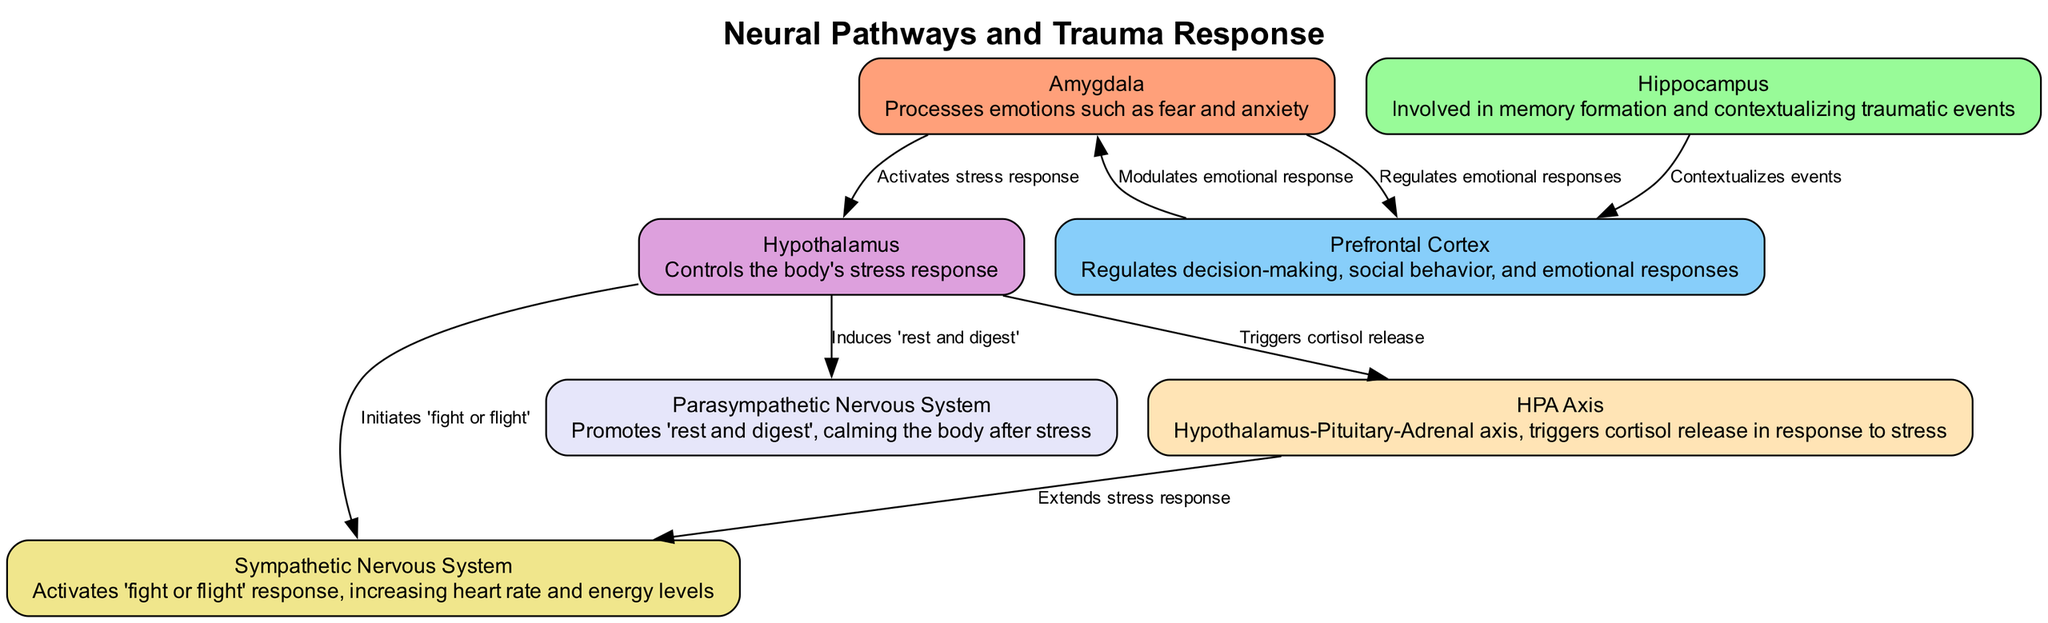What is the role of the amygdala? The amygdala processes emotions, particularly fear and anxiety, which is indicated in its description within the diagram.
Answer: Processes emotions such as fear and anxiety How many nodes are present in the diagram? By counting the individual nodes listed, there are seven distinct nodes representing different brain regions associated with trauma response.
Answer: 7 Which pathways does the hypothalamus activate? The diagram shows that the hypothalamus activates both the sympathetic nervous system ('fight or flight') and the parasympathetic nervous system ('rest and digest'), indicating its dual roles in stress response.
Answer: Sympathetic nervous system and parasympathetic nervous system What is the relationship between the amygdala and prefrontal cortex? The edge connecting these nodes indicates that the amygdala regulates emotional responses, which links it directly to the prefrontal cortex's role in modulating these responses.
Answer: Regulates emotional responses What does the HPA axis trigger in response to stress? The diagram's description of the HPA axis states that it triggers cortisol release when the hypothalamus is activated due to stress, demonstrating its role in the stress response pathway.
Answer: Triggers cortisol release How does the hippocampus interact with the prefrontal cortex? The diagram outlines that the hippocampus contextualizes events, which aids the prefrontal cortex in its functions related to decision-making and emotional regulation, showing a flow of information between these two nodes.
Answer: Contextualizes events Which system is activated by the hypothalamus during a stress response? The connection from the hypothalamus to the sympathetic nervous system indicates that it initiates the 'fight or flight' response, which is specifically noted in the edge description from the diagram.
Answer: 'Fight or flight' response What role does the prefrontal cortex have in emotional responses? According to the edge leading to the amygdala, the prefrontal cortex modulates emotional responses, thereby helping to regulate fear and anxiety initiated by the amygdala.
Answer: Modulates emotional response 